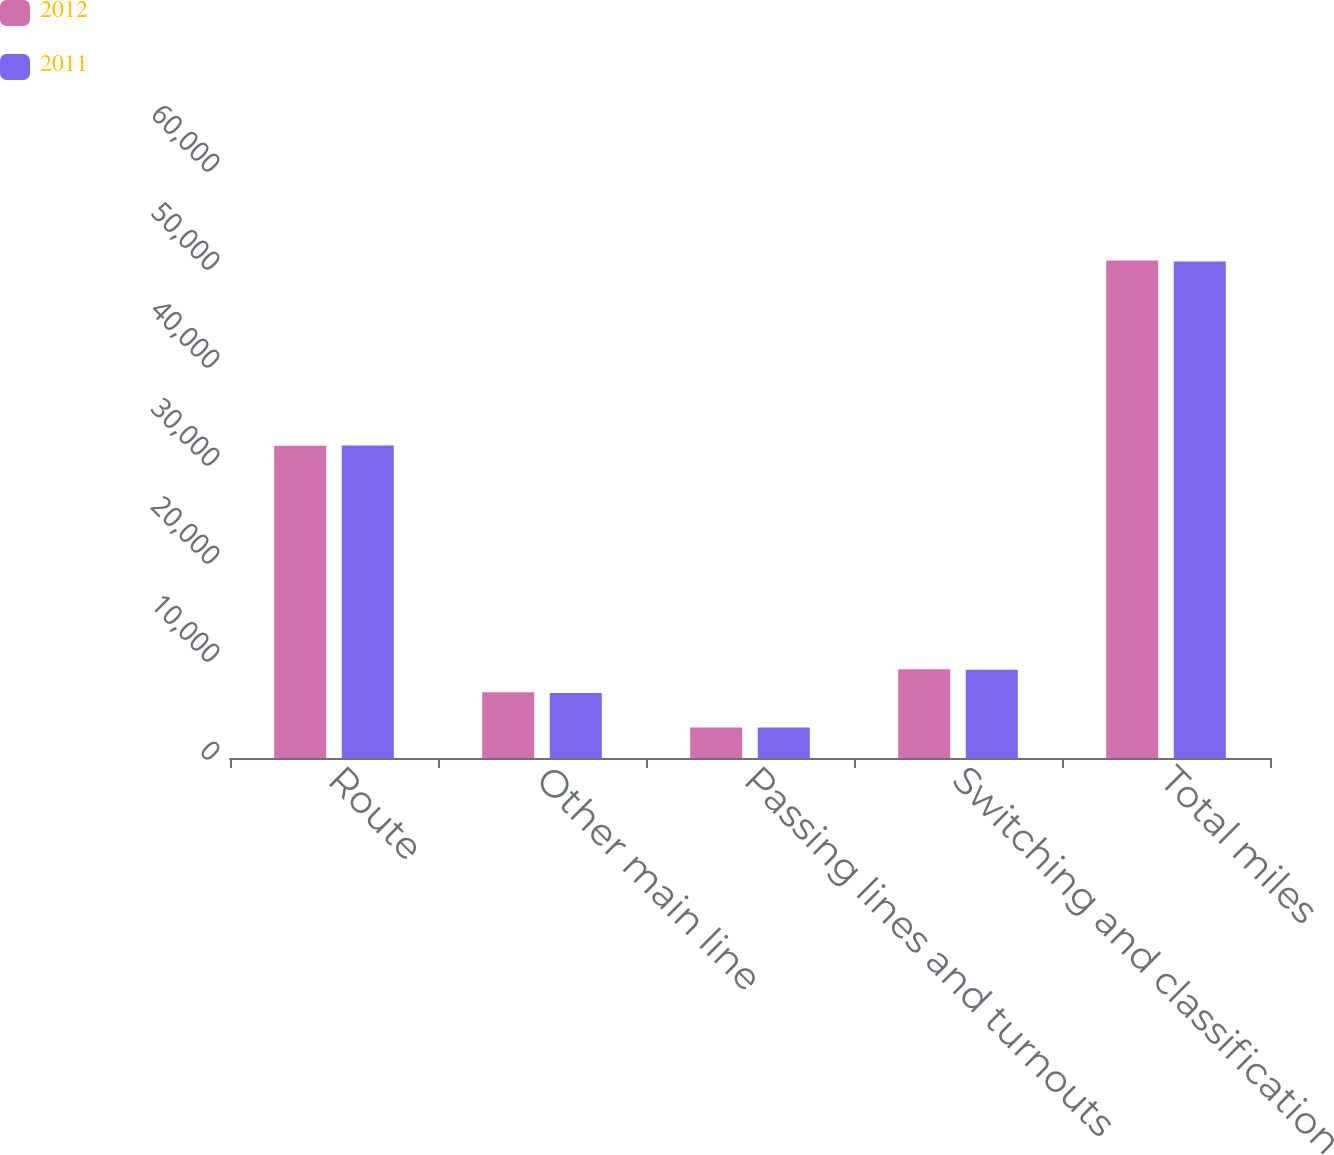Convert chart to OTSL. <chart><loc_0><loc_0><loc_500><loc_500><stacked_bar_chart><ecel><fcel>Route<fcel>Other main line<fcel>Passing lines and turnouts<fcel>Switching and classification<fcel>Total miles<nl><fcel>2012<fcel>31868<fcel>6715<fcel>3124<fcel>9046<fcel>50753<nl><fcel>2011<fcel>31898<fcel>6644<fcel>3112<fcel>8999<fcel>50653<nl></chart> 